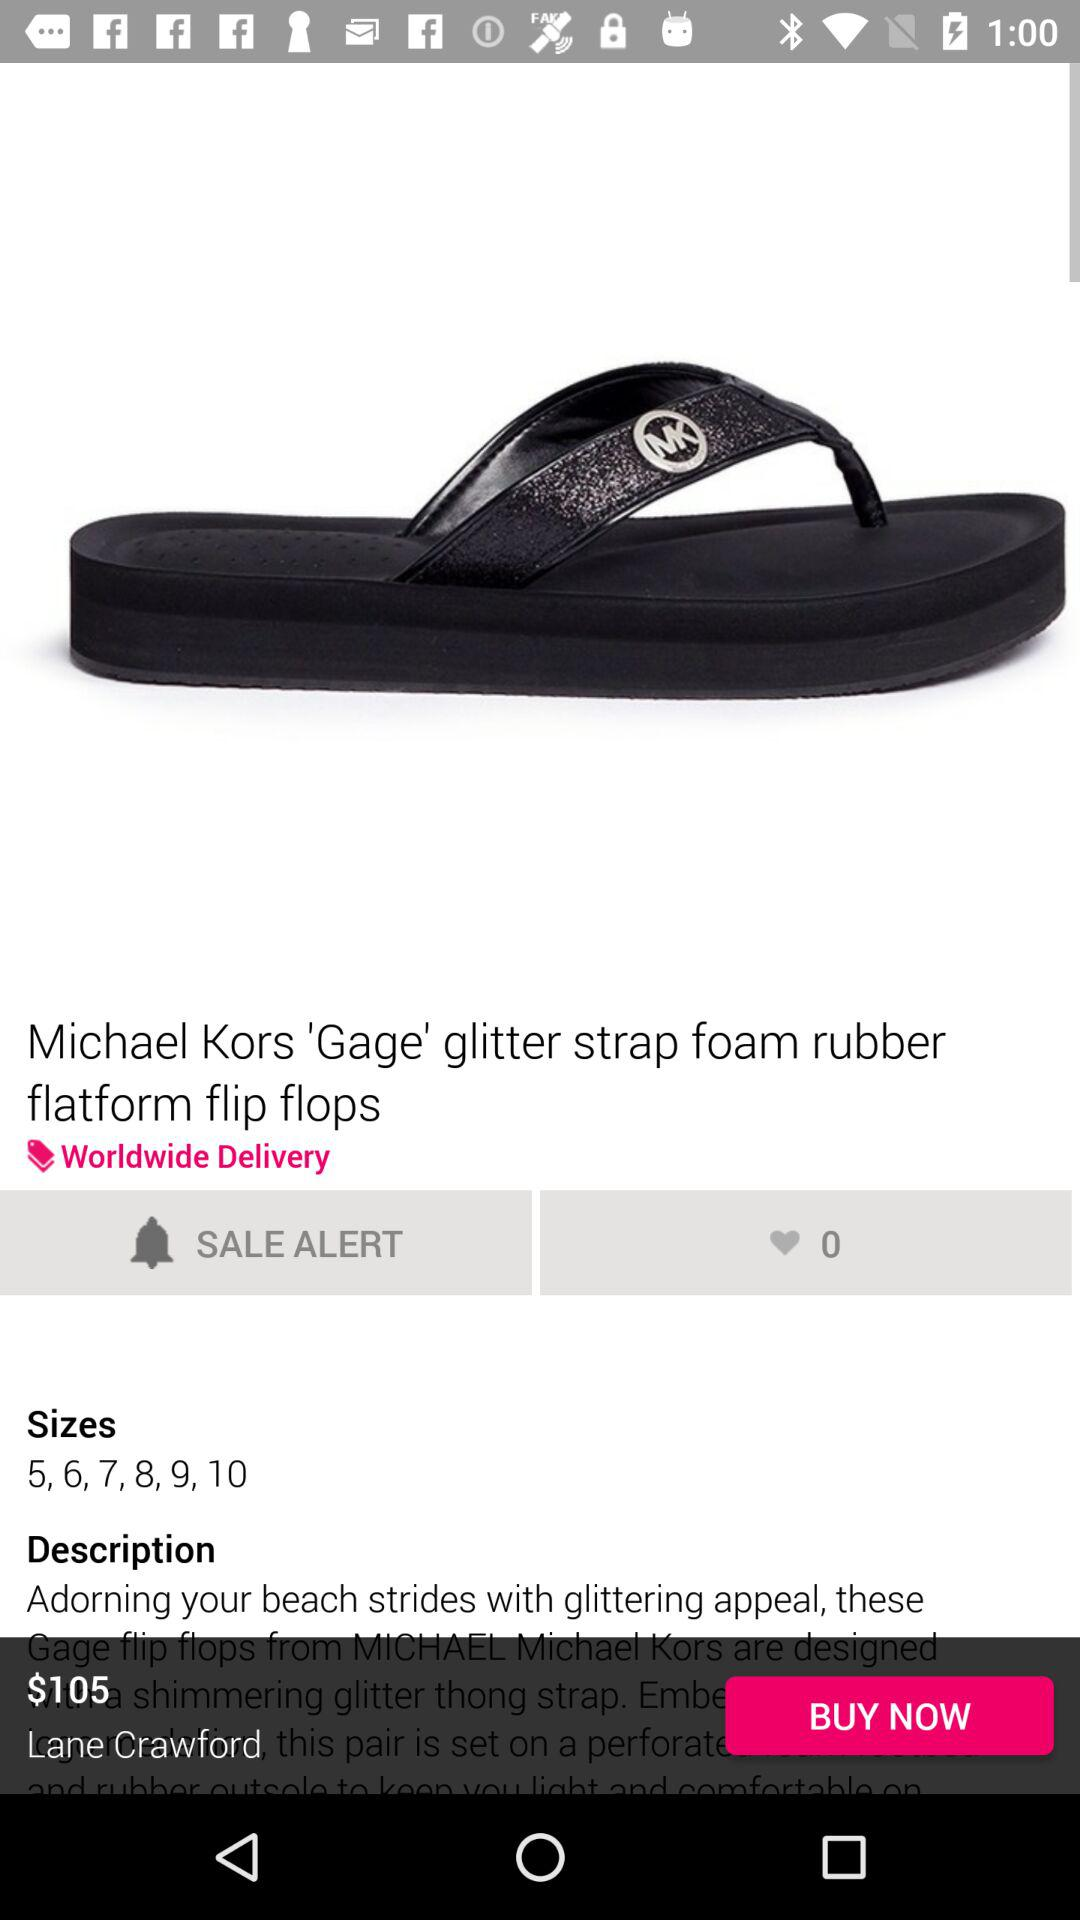What are the sizes available for the flip flops? The sizes available are 5, 6, 7, 8, 9, 10. 